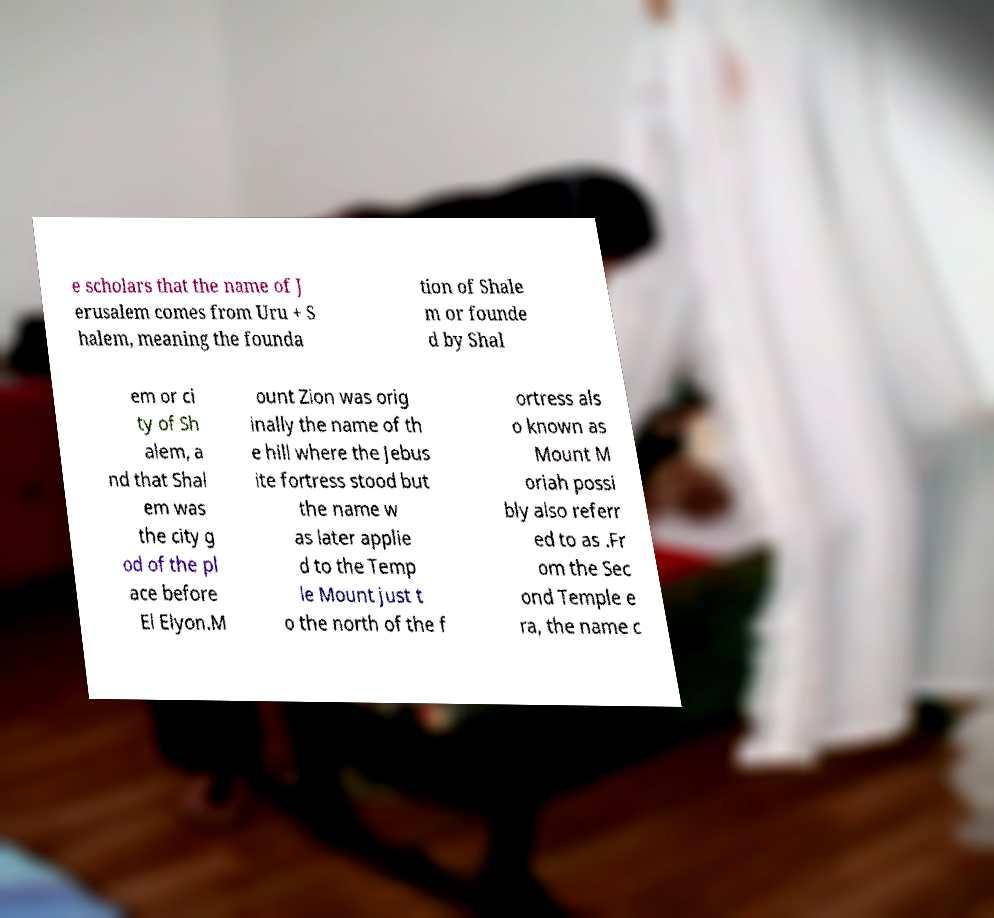For documentation purposes, I need the text within this image transcribed. Could you provide that? e scholars that the name of J erusalem comes from Uru + S halem, meaning the founda tion of Shale m or founde d by Shal em or ci ty of Sh alem, a nd that Shal em was the city g od of the pl ace before El Elyon.M ount Zion was orig inally the name of th e hill where the Jebus ite fortress stood but the name w as later applie d to the Temp le Mount just t o the north of the f ortress als o known as Mount M oriah possi bly also referr ed to as .Fr om the Sec ond Temple e ra, the name c 